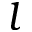<formula> <loc_0><loc_0><loc_500><loc_500>l</formula> 